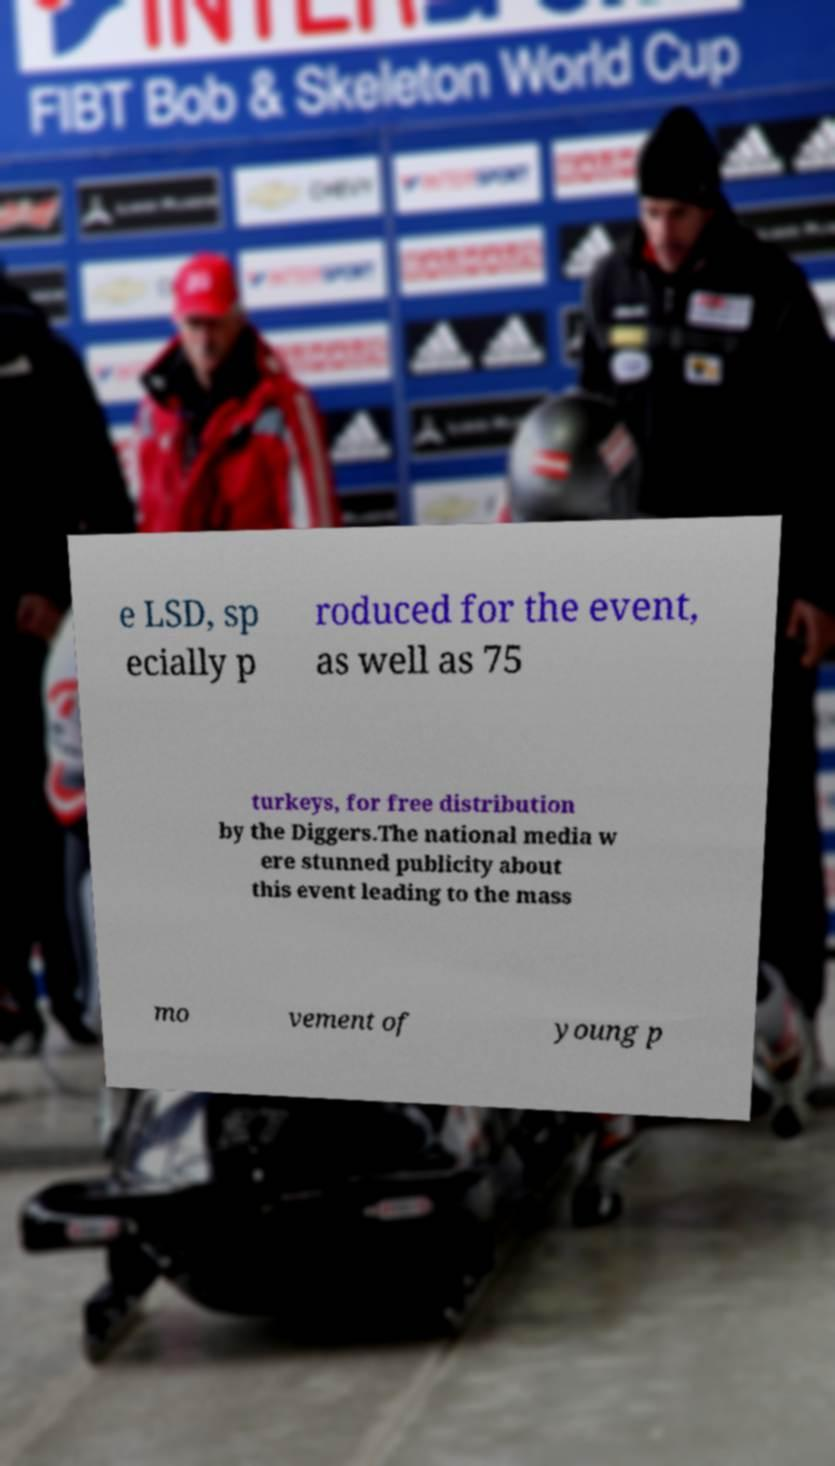What messages or text are displayed in this image? I need them in a readable, typed format. e LSD, sp ecially p roduced for the event, as well as 75 turkeys, for free distribution by the Diggers.The national media w ere stunned publicity about this event leading to the mass mo vement of young p 